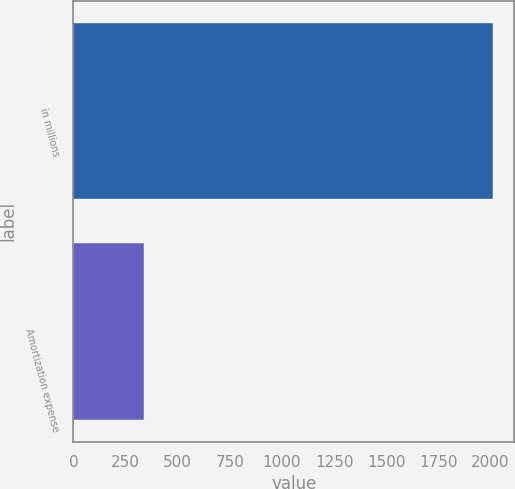Convert chart. <chart><loc_0><loc_0><loc_500><loc_500><bar_chart><fcel>in millions<fcel>Amortization expense<nl><fcel>2012<fcel>338<nl></chart> 